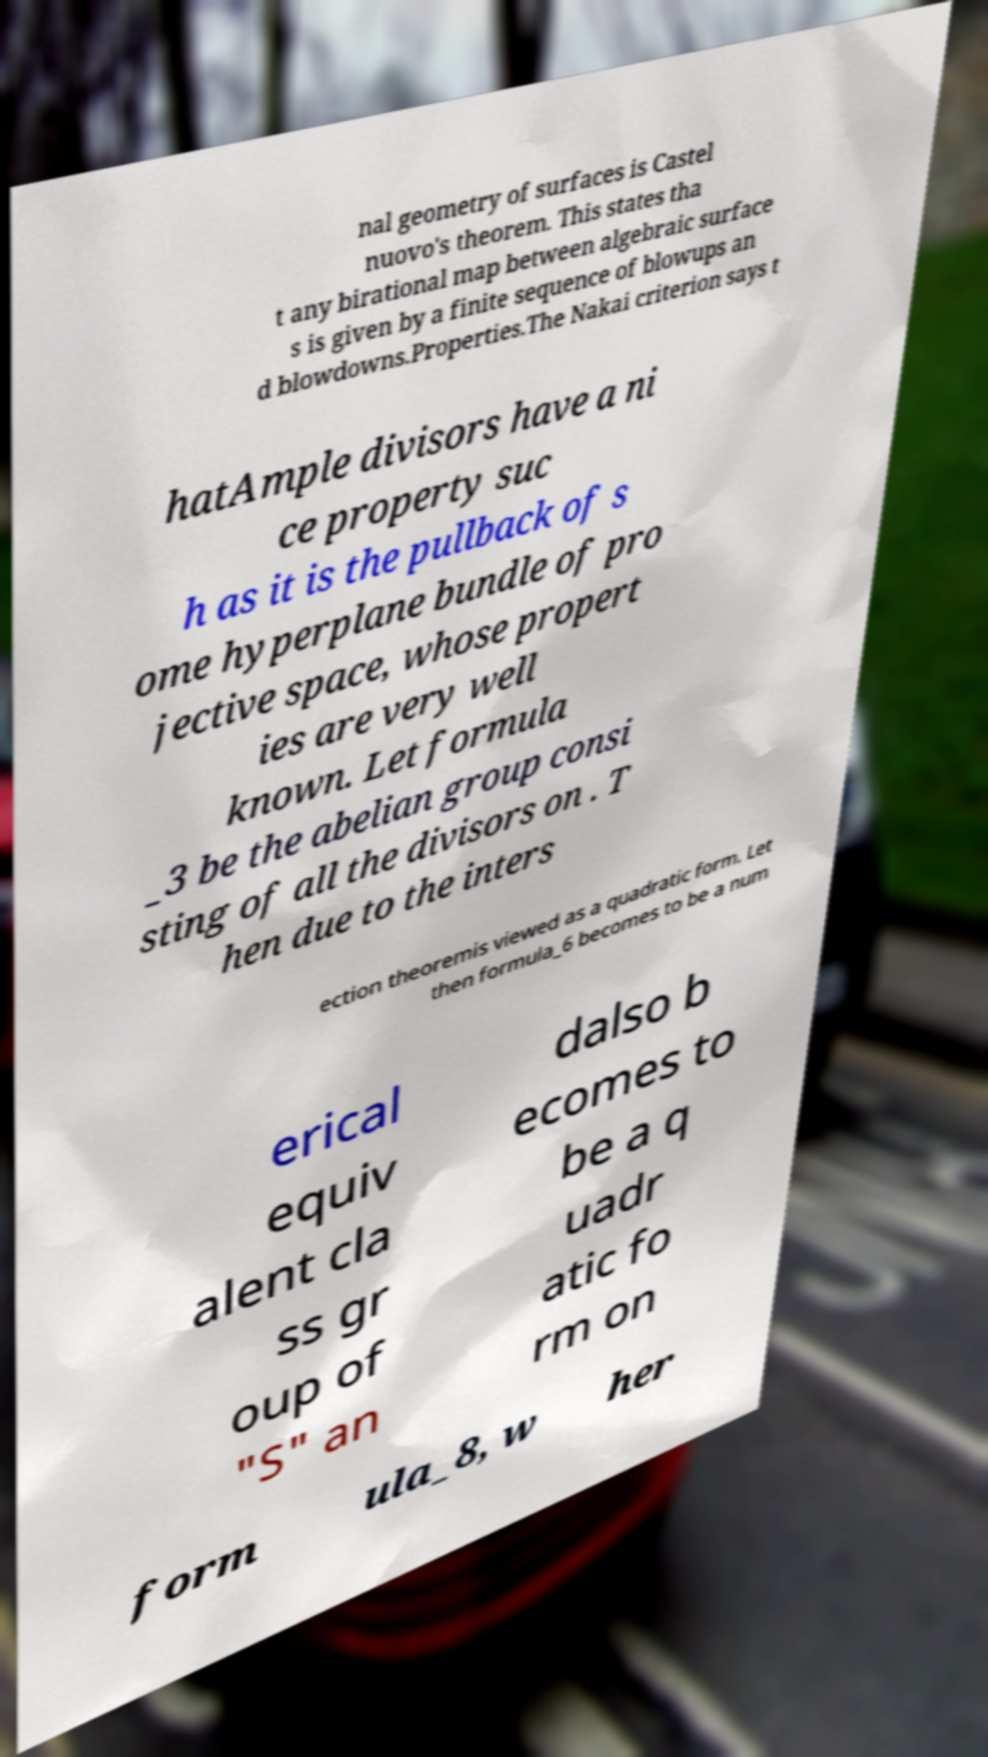I need the written content from this picture converted into text. Can you do that? nal geometry of surfaces is Castel nuovo's theorem. This states tha t any birational map between algebraic surface s is given by a finite sequence of blowups an d blowdowns.Properties.The Nakai criterion says t hatAmple divisors have a ni ce property suc h as it is the pullback of s ome hyperplane bundle of pro jective space, whose propert ies are very well known. Let formula _3 be the abelian group consi sting of all the divisors on . T hen due to the inters ection theoremis viewed as a quadratic form. Let then formula_6 becomes to be a num erical equiv alent cla ss gr oup of "S" an dalso b ecomes to be a q uadr atic fo rm on form ula_8, w her 